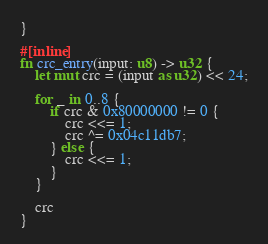<code> <loc_0><loc_0><loc_500><loc_500><_Rust_>}

#[inline]
fn crc_entry(input: u8) -> u32 {
    let mut crc = (input as u32) << 24;

    for _ in 0..8 {
        if crc & 0x80000000 != 0 {
            crc <<= 1;
            crc ^= 0x04c11db7;
        } else {
            crc <<= 1;
        }
    }

    crc
}
</code> 